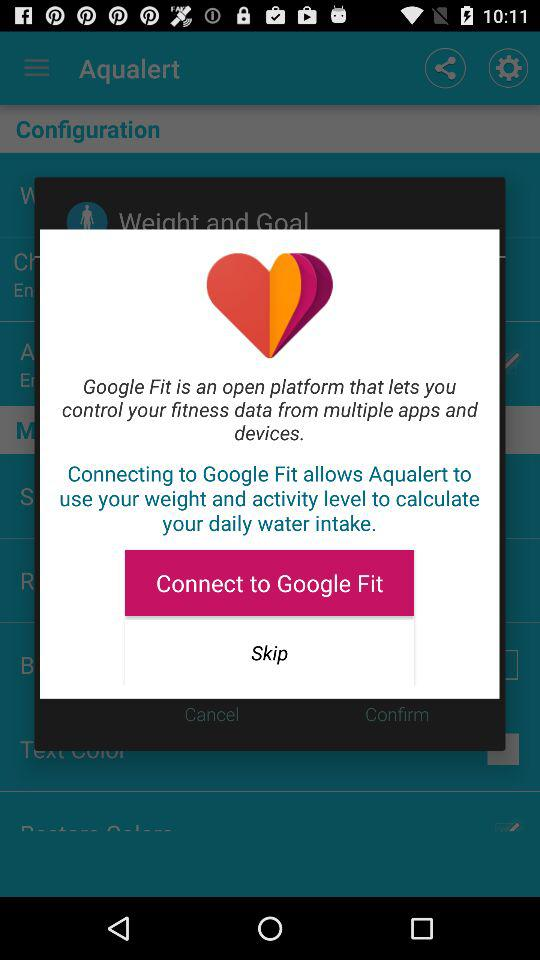What is the application name? The application names are "Aqualert" and "Google Fit". 